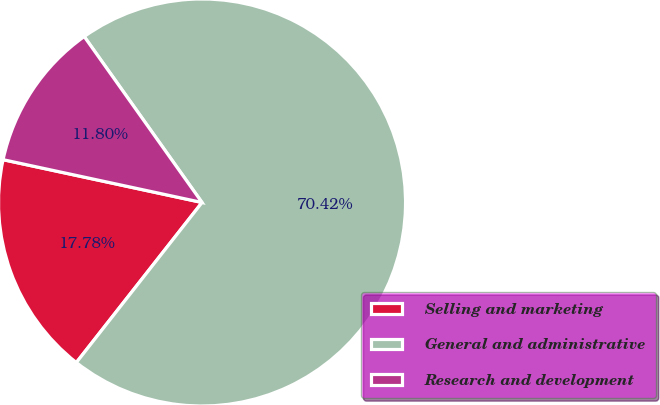<chart> <loc_0><loc_0><loc_500><loc_500><pie_chart><fcel>Selling and marketing<fcel>General and administrative<fcel>Research and development<nl><fcel>17.78%<fcel>70.42%<fcel>11.8%<nl></chart> 